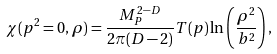Convert formula to latex. <formula><loc_0><loc_0><loc_500><loc_500>\chi ( p ^ { 2 } = 0 , \rho ) = { \frac { M _ { P } ^ { 2 - D } } { 2 \pi ( D - 2 ) } } T ( p ) \ln \left ( { \frac { \rho ^ { 2 } } { b ^ { 2 } } } \right ) ,</formula> 